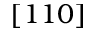<formula> <loc_0><loc_0><loc_500><loc_500>[ 1 1 0 ]</formula> 